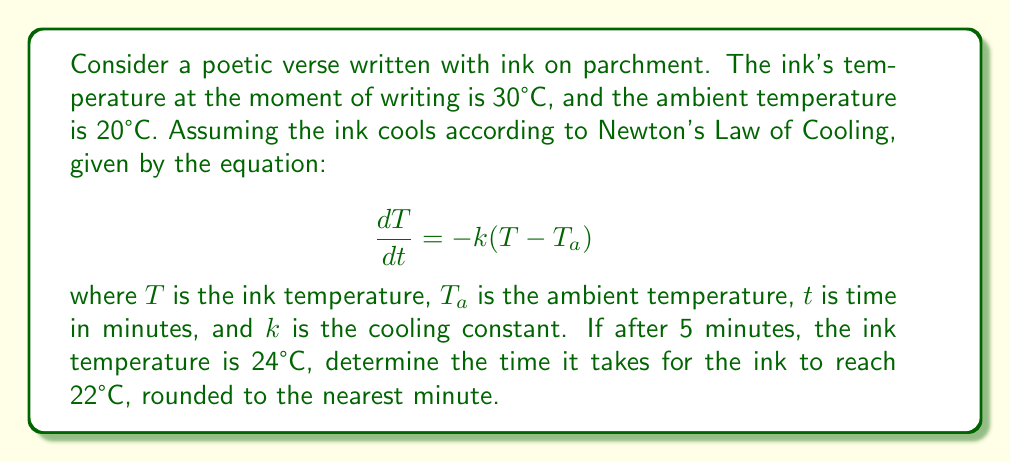Give your solution to this math problem. 1) First, we need to find the cooling constant $k$. We can use the given information:
   Initial temperature $T_0 = 30°C$
   Ambient temperature $T_a = 20°C$
   After 5 minutes, $T = 24°C$

2) The solution to Newton's Law of Cooling is:
   $$T(t) = T_a + (T_0 - T_a)e^{-kt}$$

3) Substituting the known values:
   $$24 = 20 + (30 - 20)e^{-5k}$$

4) Solving for $k$:
   $$4 = 10e^{-5k}$$
   $$0.4 = e^{-5k}$$
   $$\ln(0.4) = -5k$$
   $$k = -\frac{\ln(0.4)}{5} \approx 0.1833$$

5) Now that we have $k$, we can find the time it takes to reach 22°C:
   $$22 = 20 + (30 - 20)e^{-0.1833t}$$

6) Solving for $t$:
   $$2 = 10e^{-0.1833t}$$
   $$0.2 = e^{-0.1833t}$$
   $$\ln(0.2) = -0.1833t$$
   $$t = -\frac{\ln(0.2)}{0.1833} \approx 8.79 \text{ minutes}$$

7) Rounding to the nearest minute:
   $t \approx 9 \text{ minutes}$
Answer: 9 minutes 